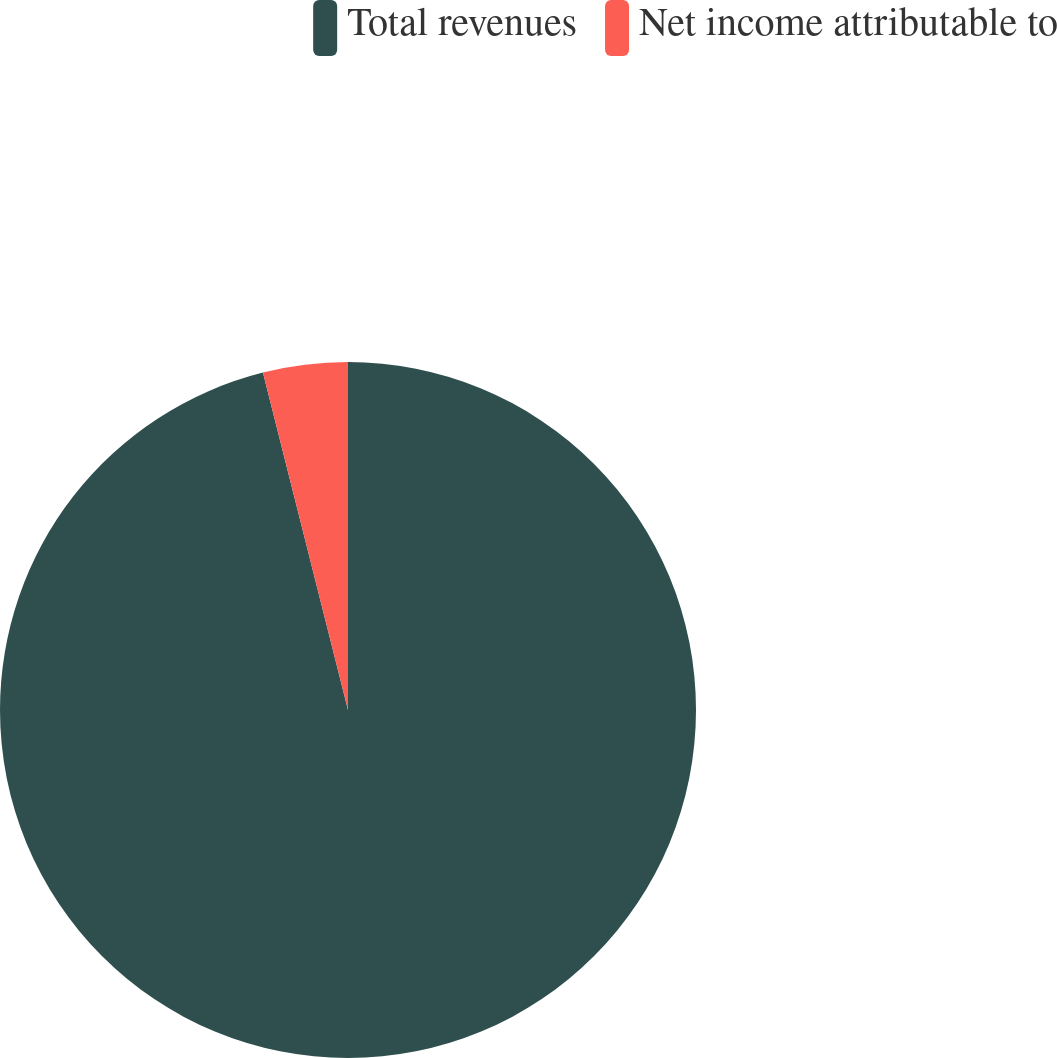Convert chart. <chart><loc_0><loc_0><loc_500><loc_500><pie_chart><fcel>Total revenues<fcel>Net income attributable to<nl><fcel>96.07%<fcel>3.93%<nl></chart> 